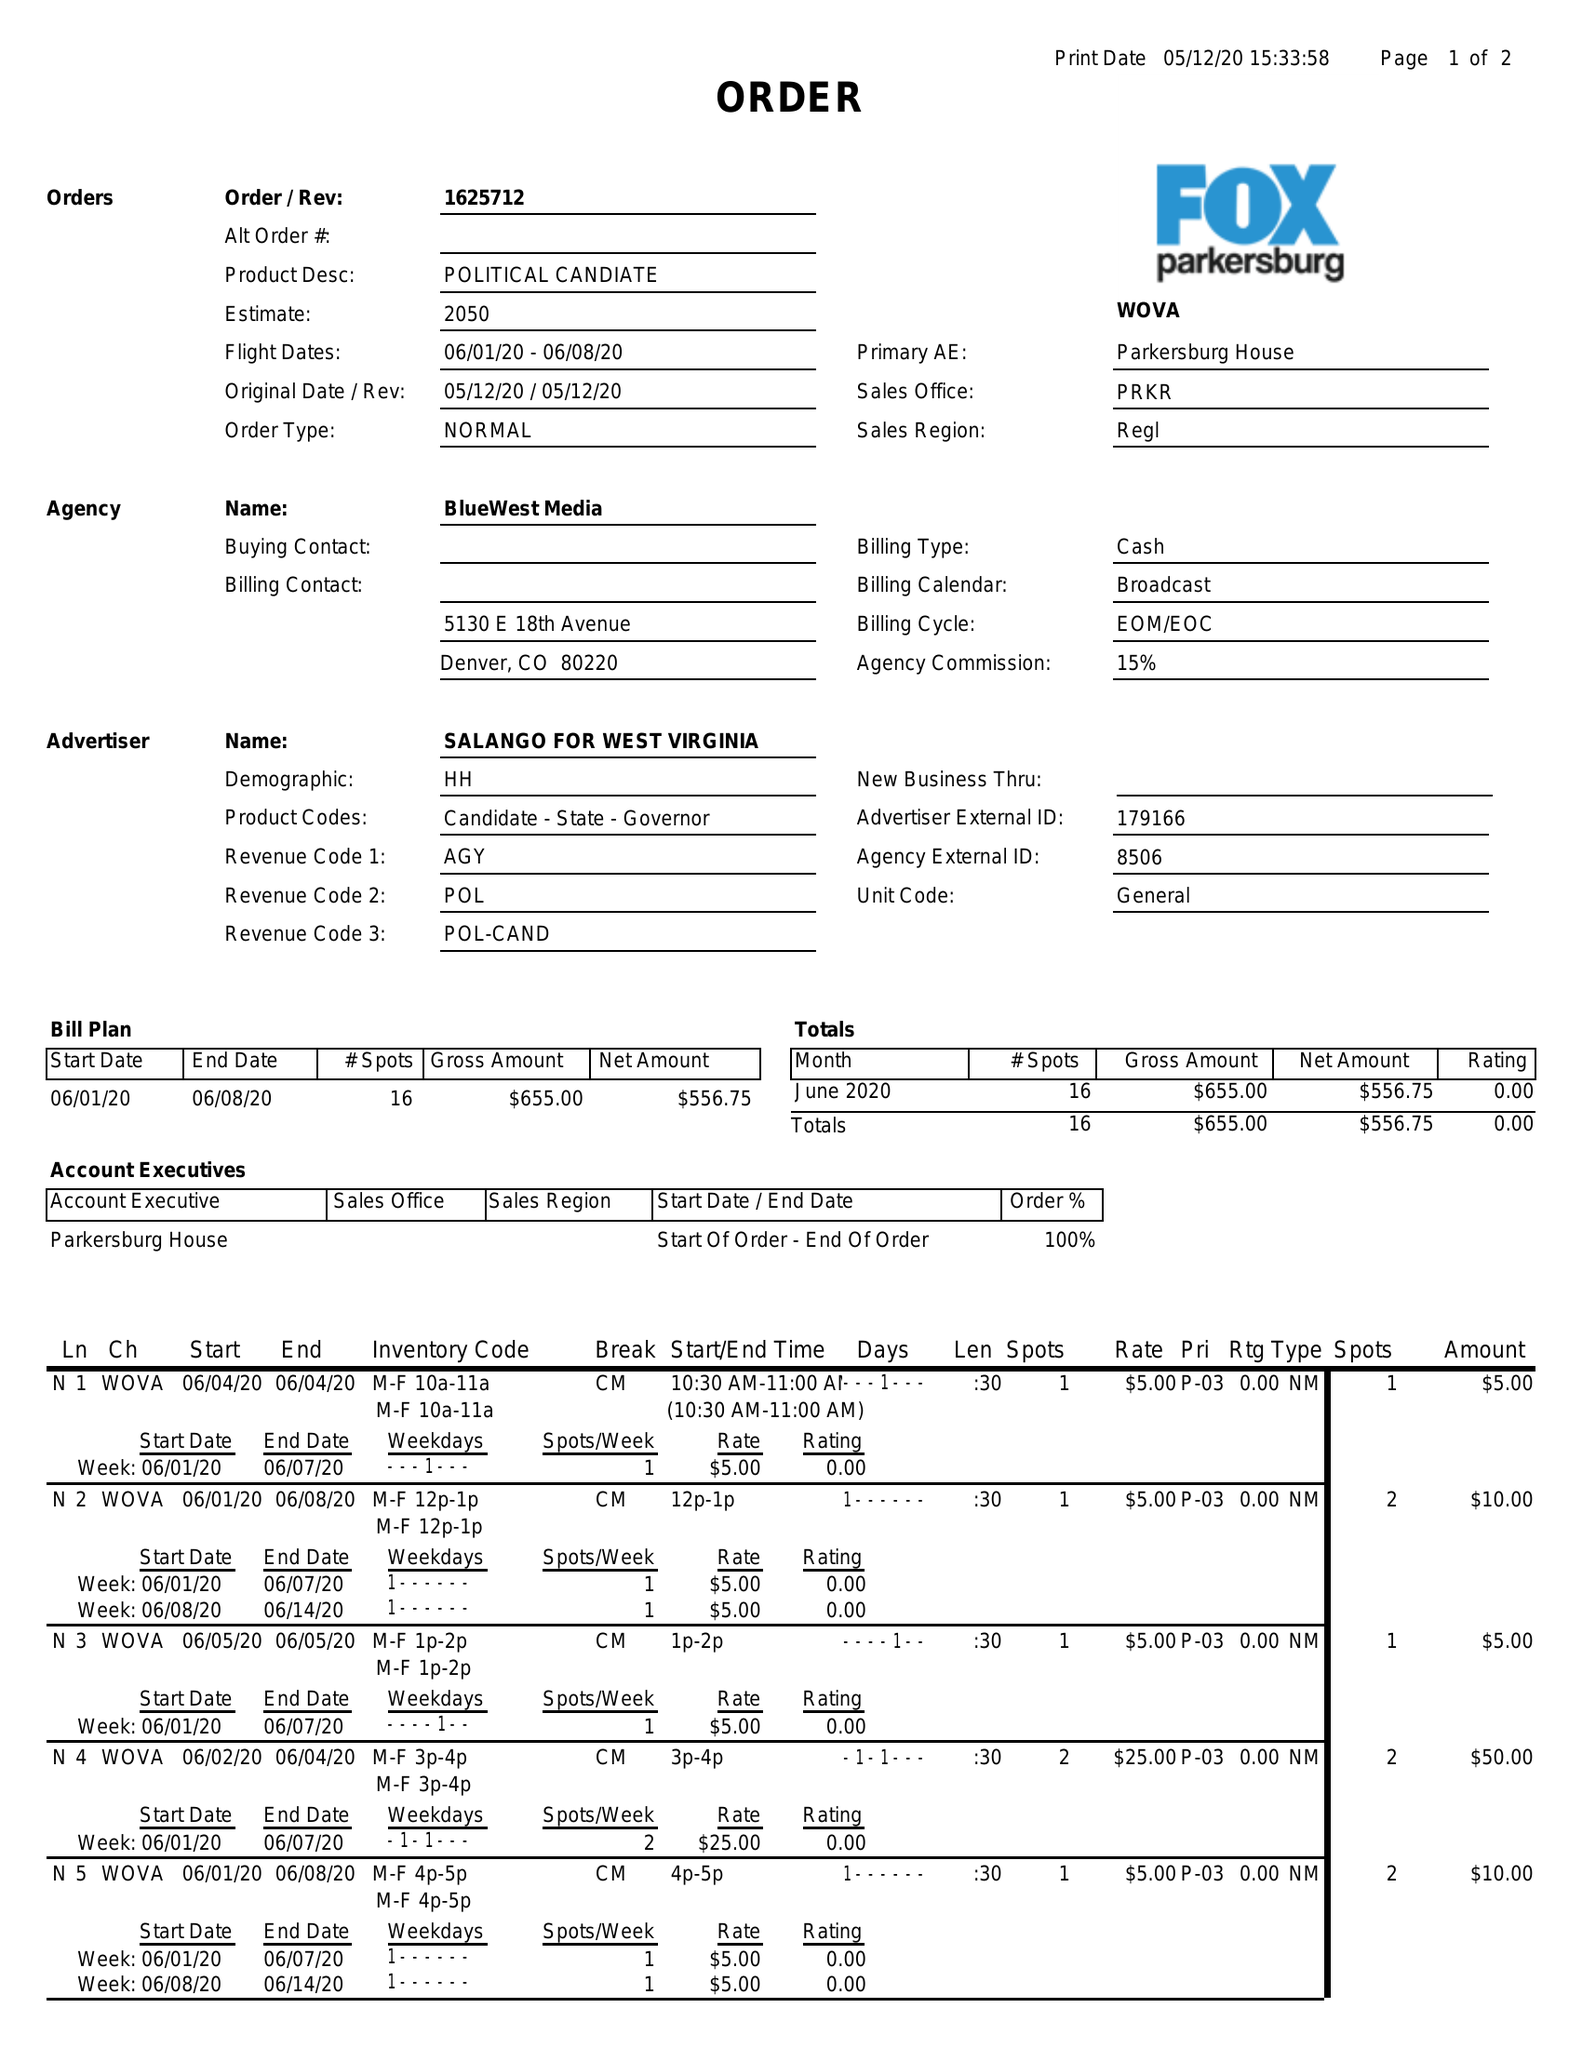What is the value for the contract_num?
Answer the question using a single word or phrase. 1625712 